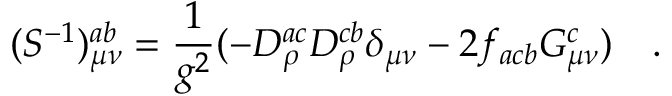<formula> <loc_0><loc_0><loc_500><loc_500>( S ^ { - 1 } ) _ { \mu \nu } ^ { a b } = { \frac { 1 } { g ^ { 2 } } } ( - D _ { \rho } ^ { a c } D _ { \rho } ^ { c b } \delta _ { \mu \nu } - 2 f _ { a c b } G _ { \mu \nu } ^ { c } ) \quad .</formula> 